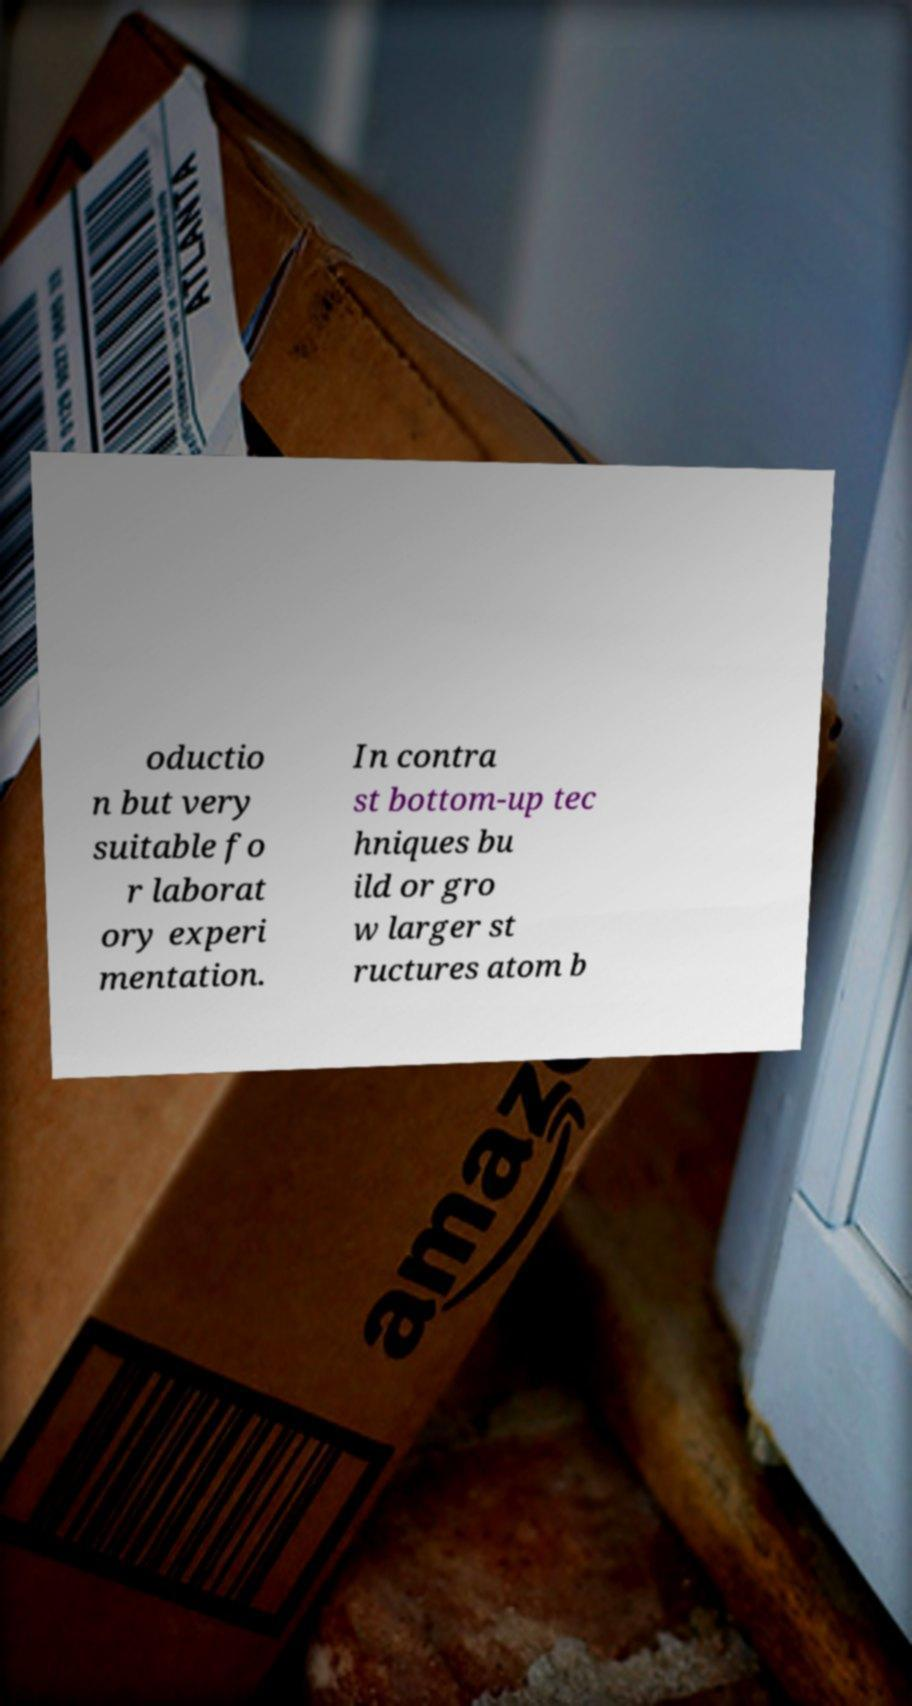I need the written content from this picture converted into text. Can you do that? oductio n but very suitable fo r laborat ory experi mentation. In contra st bottom-up tec hniques bu ild or gro w larger st ructures atom b 